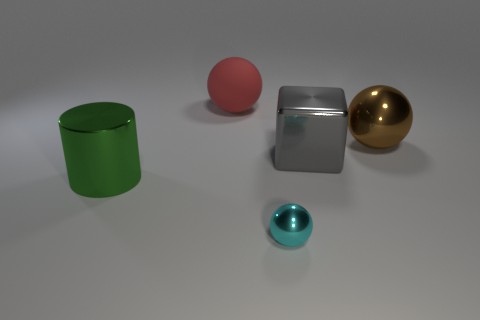The metal block has what size?
Make the answer very short. Large. Are there more small shiny objects that are behind the rubber thing than red things that are right of the brown metallic sphere?
Ensure brevity in your answer.  No. There is a tiny object; are there any big green cylinders behind it?
Offer a terse response. Yes. Are there any brown spheres that have the same size as the cyan sphere?
Make the answer very short. No. What is the color of the big cube that is the same material as the tiny sphere?
Your response must be concise. Gray. What is the large green cylinder made of?
Your answer should be very brief. Metal. The large gray object has what shape?
Give a very brief answer. Cube. How many tiny things are the same color as the large cylinder?
Your answer should be compact. 0. What material is the big sphere that is behind the big sphere that is on the right side of the metallic ball left of the brown metal object?
Ensure brevity in your answer.  Rubber. What number of purple things are either large metal cylinders or tiny cylinders?
Provide a short and direct response. 0. 